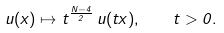<formula> <loc_0><loc_0><loc_500><loc_500>u ( x ) \mapsto t ^ { \frac { N - 4 } { 2 } } \, u ( t x ) , \quad t > 0 .</formula> 